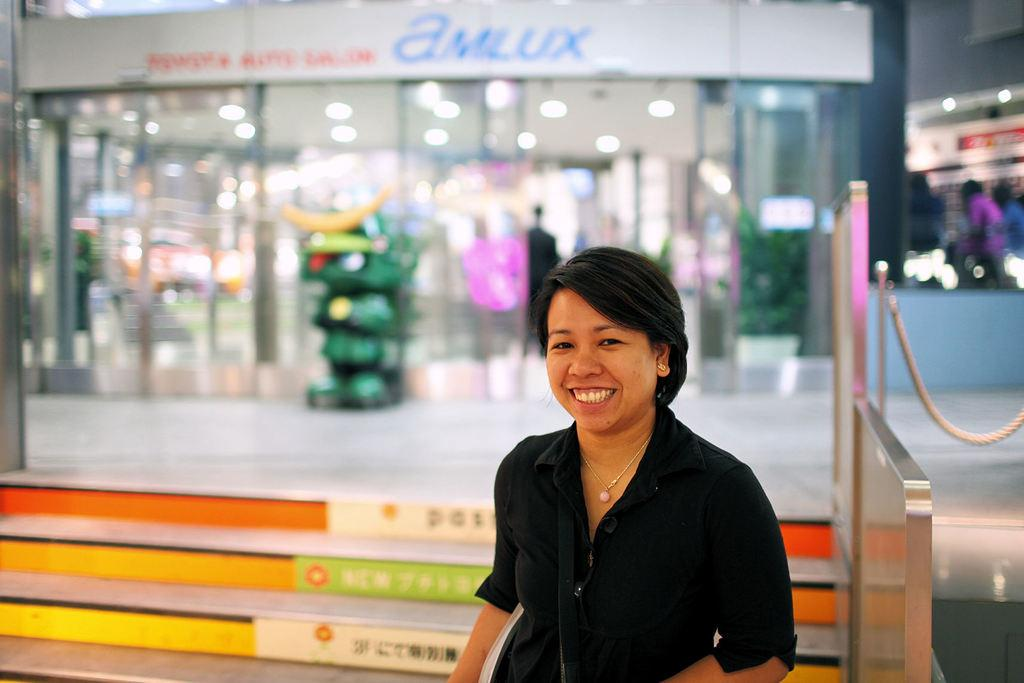Who is present in the image? There is a woman in the image. What is the woman doing in the image? The woman is laughing. Can you describe the background of the image? The background of the image is blurry. What type of reward is the woman receiving from the minister in the image? There is no minister or reward present in the image; it only features a woman laughing. 